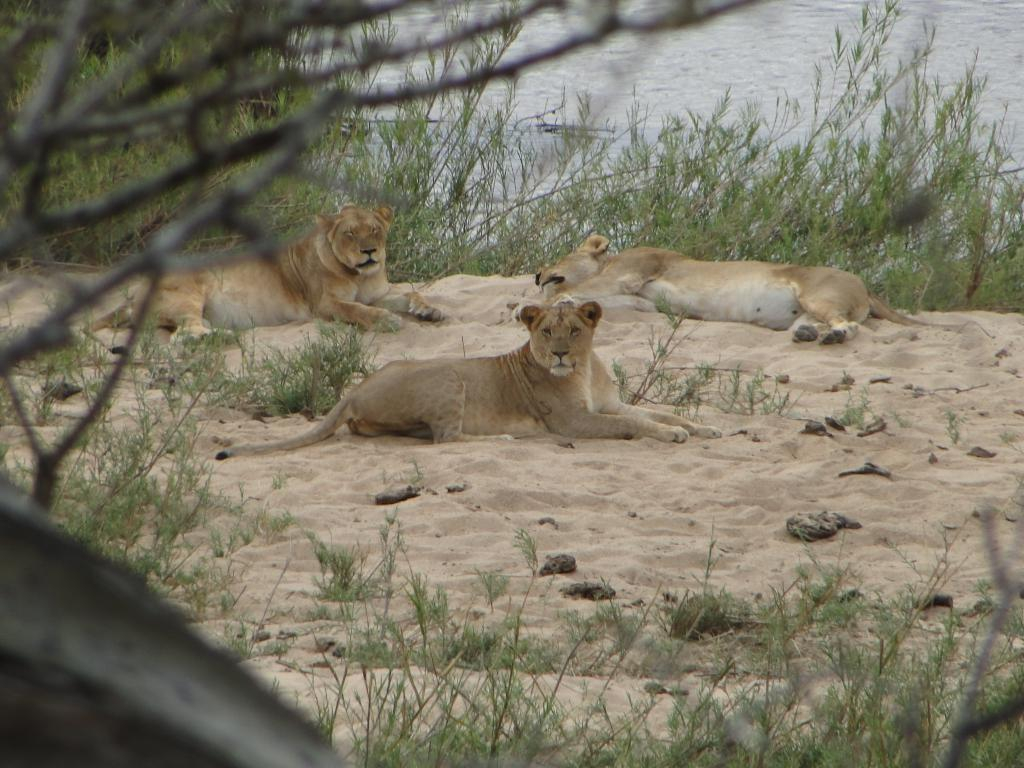What type of vegetation is present in the image? There is grass in the image. What else can be seen in the image besides grass? There are branches and lions visible in the image. What type of terrain is present in the image? There is sand in the image. What can be seen in the background of the image? There is water visible in the background of the image. How many cattle are sitting on the seat in the image? There are no cattle or seats present in the image. What type of voyage are the lions embarking on in the image? There is no indication of a voyage in the image; the lions are simply visible in their natural habitat. 